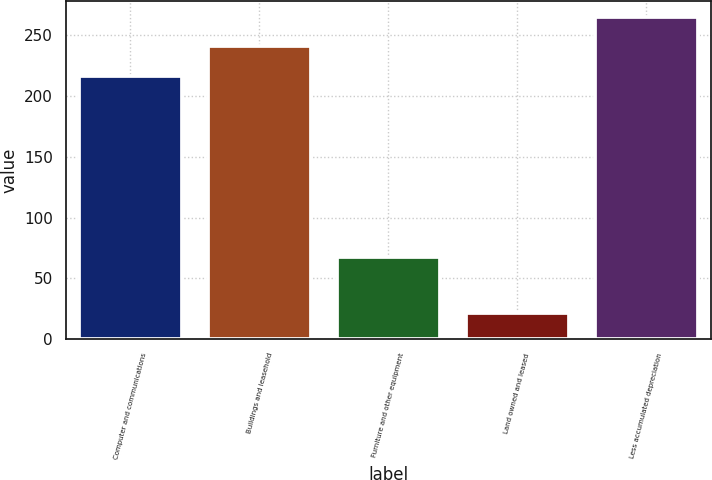Convert chart. <chart><loc_0><loc_0><loc_500><loc_500><bar_chart><fcel>Computer and communications<fcel>Buildings and leasehold<fcel>Furniture and other equipment<fcel>Land owned and leased<fcel>Less accumulated depreciation<nl><fcel>216.6<fcel>240.77<fcel>67.7<fcel>21.5<fcel>264.94<nl></chart> 